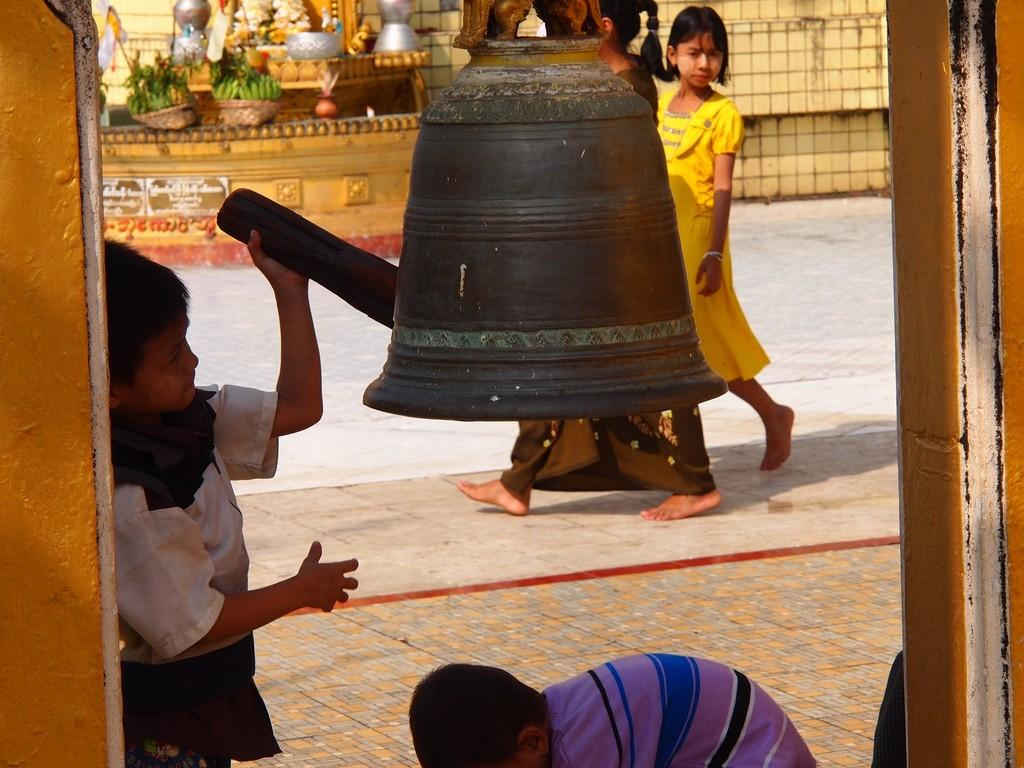Who is the main subject in the image? There is a boy in the image. What is the boy doing in the image? The boy is ringing a bell. What is the surface beneath the boy in the image? There is a floor at the bottom of the image. What can be seen in the background of the image? There are people walking in the background of the image. What is located to the left of the boy in the image? There is a wall to the left of the image. What type of umbrella is the spy using to hide in the image? There is no spy or umbrella present in the image. What school does the boy attend, as seen in the image? The image does not provide any information about the boy's school or education. 